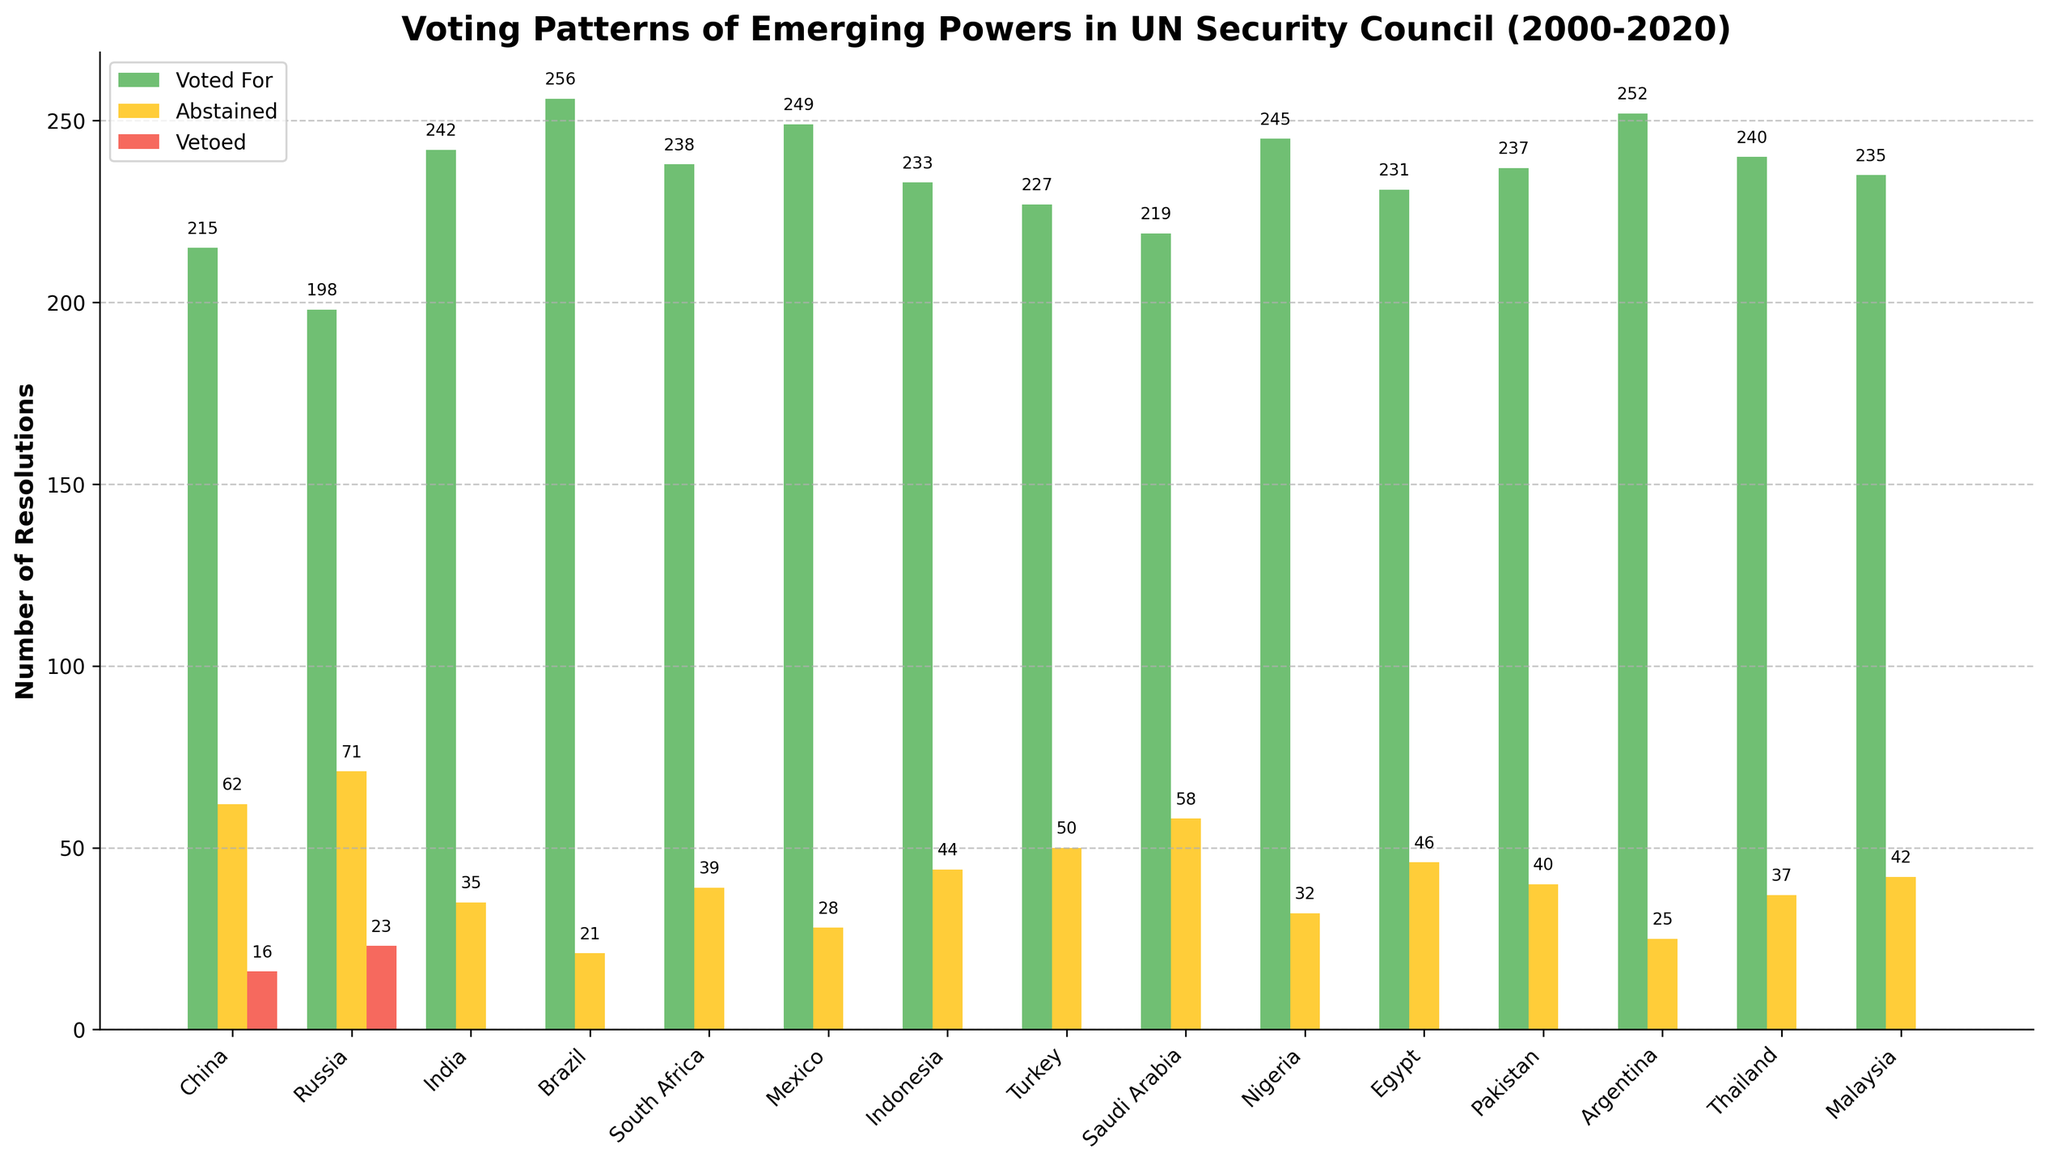Which country voted for the most resolutions? Looking at the bar representing "Resolutions Voted For," Brazil has the tallest bar, indicating it voted for the most resolutions.
Answer: Brazil Which two countries have the highest number of abstained votes combined? Adding the abstained votes for China (62) and Russia (71) results in a total of 62 + 71 = 133, which is higher than any other pair of countries.
Answer: China and Russia What is the total number of resolutions vetoed by China and Russia together? Adding the vetoes of China and Russia, 16 + 23 = 39.
Answer: 39 Which country has the least number of abstained votes? The country with the shortest bar for "Resolutions Abstained" is Brazil, with 21 abstained votes.
Answer: Brazil What is the difference between the resolutions India voted for and those it abstained from? Subtracting India's abstained votes (35) from its voted-for resolutions (242), 242 - 35 = 207.
Answer: 207 Between Argentina and Brazil, which country abstained from fewer resolutions, and by how much? Argentina has 25 abstained votes, Brazil has 21. The difference is 25 - 21 = 4. So, Brazil abstained from fewer resolutions by 4.
Answer: Brazil by 4 How many resolutions did Mexico vote for on average per year between 2000 and 2020? Mexico voted for 249 resolutions over 21 years. 249 / 21 ≈ 11.86 resolutions per year.
Answer: Approximately 11.86 Which countries have no vetoed resolutions? Observing the "Resolutions Vetoed" bars, India, Brazil, South Africa, Mexico, Indonesia, Turkey, Saudi Arabia, Nigeria, Egypt, Pakistan, Argentina, Thailand, and Malaysia have zero vetoed resolutions.
Answer: India, Brazil, South Africa, Mexico, Indonesia, Turkey, Saudi Arabia, Nigeria, Egypt, Pakistan, Argentina, Thailand, Malaysia How many more resolutions did Nigeria vote for compared to Indonesia? Nigeria voted for 245 resolutions, while Indonesia voted for 233. The difference is 245 - 233 = 12.
Answer: 12 Which country abstained from more resolutions, Malaysia or South Africa, and by how many? Malaysia abstained from 42 resolutions, while South Africa abstained from 39. The difference is 42 - 39 = 3. So, Malaysia abstained from 3 more resolutions than South Africa.
Answer: Malaysia by 3 